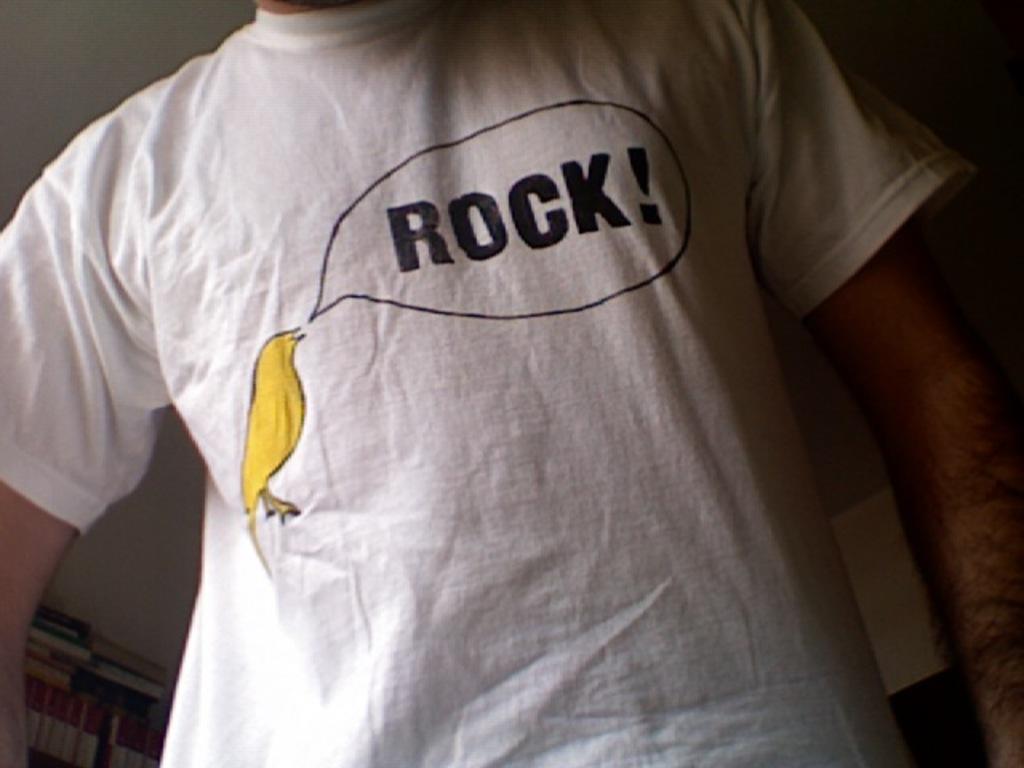What is the bird saying?
Your answer should be compact. Rock. 